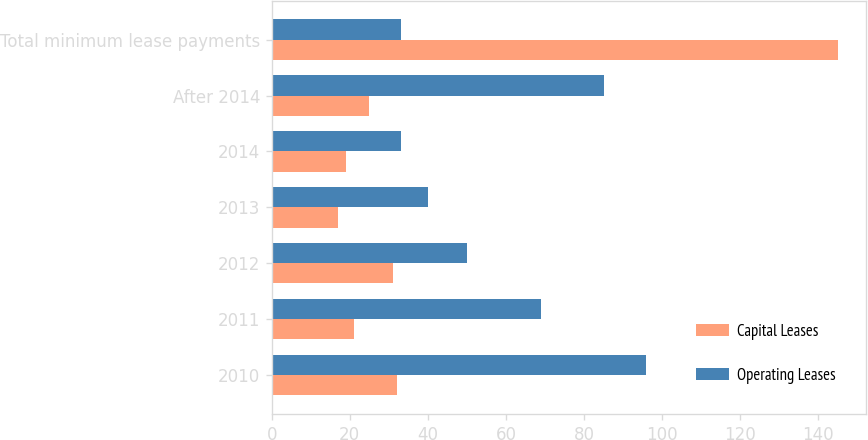Convert chart. <chart><loc_0><loc_0><loc_500><loc_500><stacked_bar_chart><ecel><fcel>2010<fcel>2011<fcel>2012<fcel>2013<fcel>2014<fcel>After 2014<fcel>Total minimum lease payments<nl><fcel>Capital Leases<fcel>32<fcel>21<fcel>31<fcel>17<fcel>19<fcel>25<fcel>145<nl><fcel>Operating Leases<fcel>96<fcel>69<fcel>50<fcel>40<fcel>33<fcel>85<fcel>33<nl></chart> 